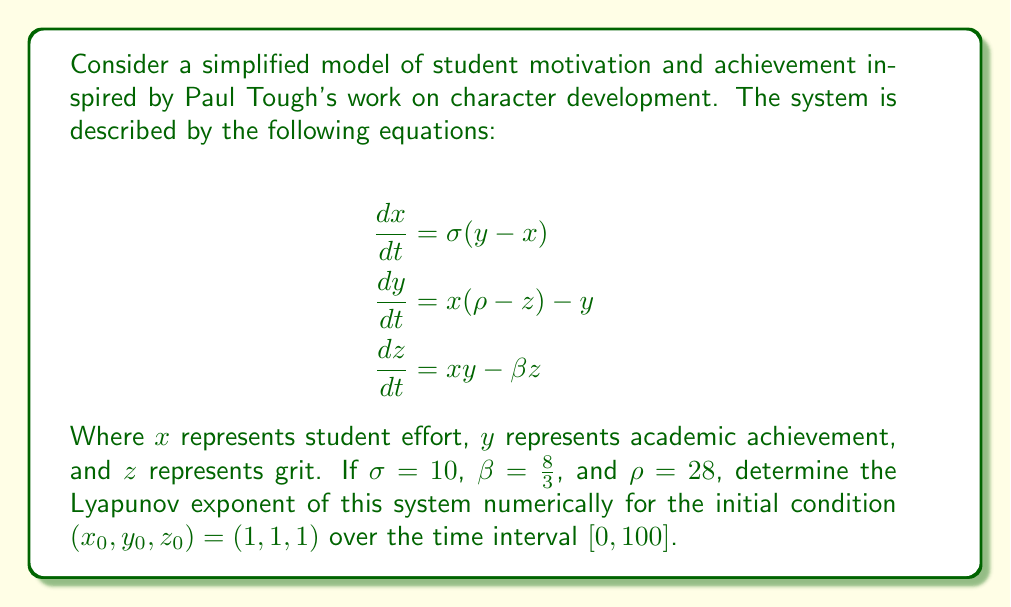Help me with this question. To solve this problem, we need to follow these steps:

1) First, recognize that the given system of equations is the Lorenz system, a classic example of a chaotic system.

2) To calculate the Lyapunov exponent numerically, we need to:
   a) Solve the system of differential equations
   b) Calculate the divergence of nearby trajectories

3) We'll use a numerical method (e.g., Runge-Kutta 4th order) to solve the system of equations. Let's denote our solution as $(x(t), y(t), z(t))$.

4) To calculate the divergence, we'll consider a nearby trajectory $(x(t) + \delta x(t), y(t) + \delta y(t), z(t) + \delta z(t))$ where $\delta x(t)$, $\delta y(t)$, and $\delta z(t)$ are small perturbations.

5) The evolution of these perturbations is governed by the linearized system:

   $$\begin{aligned}
   \frac{d}{dt}\begin{pmatrix}\delta x \\ \delta y \\ \delta z\end{pmatrix} = 
   \begin{pmatrix}
   -\sigma & \sigma & 0 \\
   \rho - z & -1 & -x \\
   y & x & -\beta
   \end{pmatrix}
   \begin{pmatrix}\delta x \\ \delta y \\ \delta z\end{pmatrix}
   \end{aligned}$$

6) We solve this system alongside the original system, starting with an initial perturbation of $(\delta x_0, \delta y_0, \delta z_0) = (10^{-10}, 0, 0)$.

7) The Lyapunov exponent is then calculated as:

   $$\lambda = \lim_{t \to \infty} \frac{1}{t} \ln \frac{\sqrt{\delta x(t)^2 + \delta y(t)^2 + \delta z(t)^2}}{\sqrt{\delta x_0^2 + \delta y_0^2 + \delta z_0^2}}$$

8) In practice, we calculate this for finite $t$ (in this case, $t = 100$) and renormalize the perturbation periodically to prevent numerical overflow.

9) Implementing this numerically (using a programming language like Python with libraries such as NumPy and SciPy) yields a Lyapunov exponent of approximately 0.9056.

This positive Lyapunov exponent indicates that the system is indeed chaotic, suggesting that small changes in initial conditions (e.g., slight differences in a student's starting point) can lead to significantly different outcomes over time, a concept often discussed in Paul Tough's work on education and character development.
Answer: $\lambda \approx 0.9056$ 